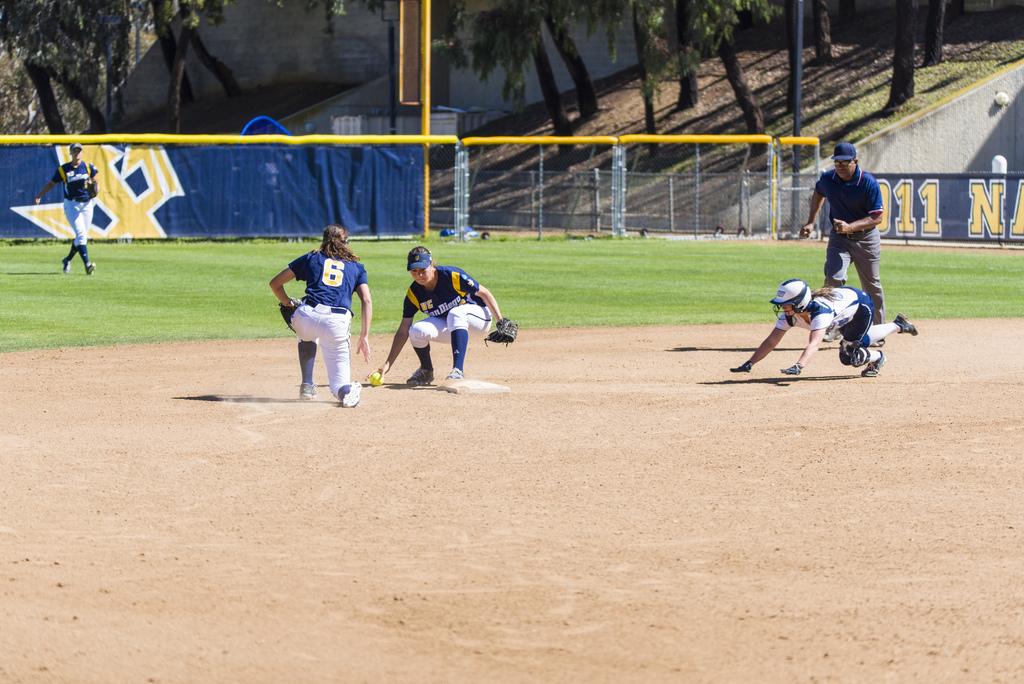What is number on the one who is kneeling?
Ensure brevity in your answer.  6. What city name is on the jersey of the team on defense?
Ensure brevity in your answer.  San diego. 